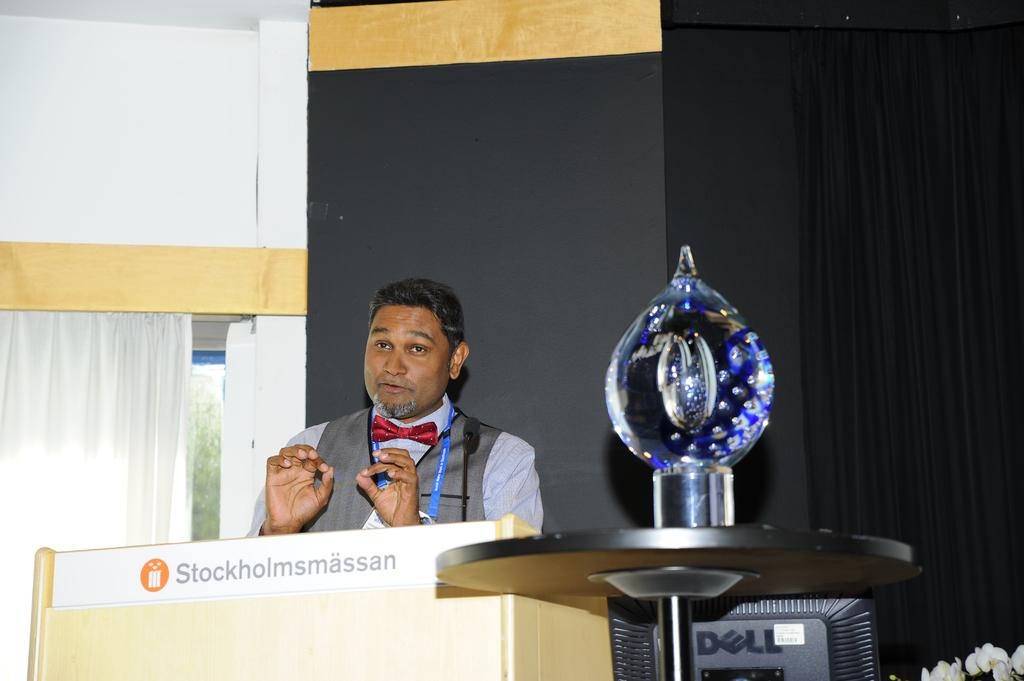Who is the main subject in the image? There is a man in the image. What is the man doing in the image? The man is standing near a podium and speaking. What can be seen behind the man? There is a wall behind the man. What type of hat is the man's mom wearing in the image? There is no mention of a hat or the man's mom in the image, so we cannot answer that question. 